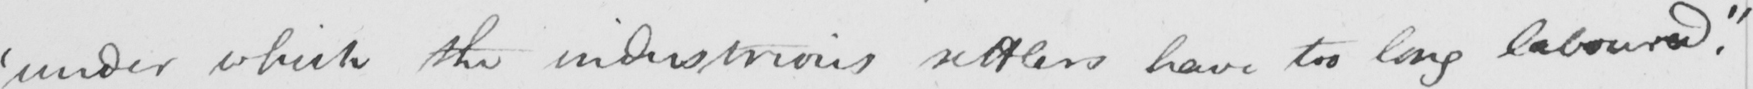Please provide the text content of this handwritten line. ' under which the industrious settlers have too long laboured . " 